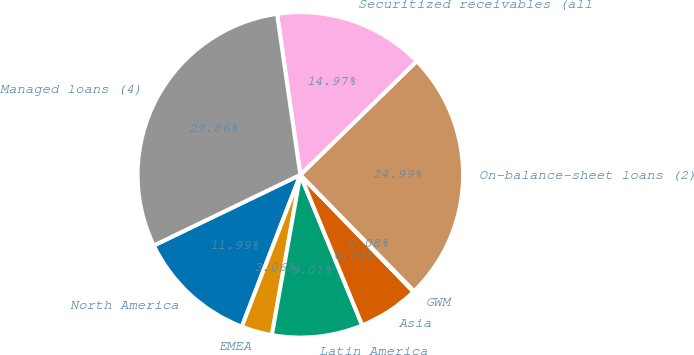Convert chart to OTSL. <chart><loc_0><loc_0><loc_500><loc_500><pie_chart><fcel>North America<fcel>EMEA<fcel>Latin America<fcel>Asia<fcel>GWM<fcel>On-balance-sheet loans (2)<fcel>Securitized receivables (all<fcel>Managed loans (4)<nl><fcel>11.99%<fcel>3.06%<fcel>9.01%<fcel>6.03%<fcel>0.08%<fcel>24.99%<fcel>14.97%<fcel>29.86%<nl></chart> 